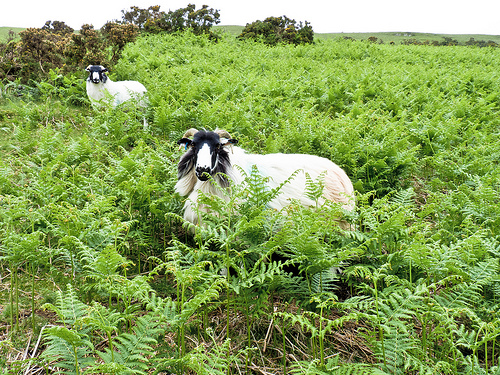Please provide a short description for this region: [0.35, 0.37, 0.74, 0.67]. The image captures a goat with a distinctive black face, amidst a lush green backdrop, adding a striking contrast to the scene. 